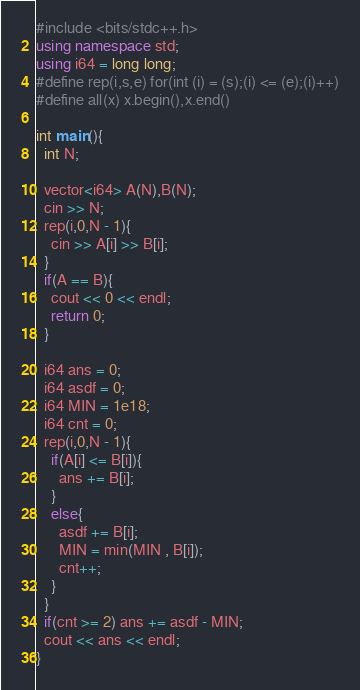Convert code to text. <code><loc_0><loc_0><loc_500><loc_500><_C++_>#include <bits/stdc++.h>
using namespace std;
using i64 = long long;
#define rep(i,s,e) for(int (i) = (s);(i) <= (e);(i)++)
#define all(x) x.begin(),x.end()

int main(){
  int N;
 
  vector<i64> A(N),B(N);
  cin >> N;
  rep(i,0,N - 1){
    cin >> A[i] >> B[i];
  }
  if(A == B){
    cout << 0 << endl;
    return 0;
  }

  i64 ans = 0;
  i64 asdf = 0;
  i64 MIN = 1e18;
  i64 cnt = 0;
  rep(i,0,N - 1){
    if(A[i] <= B[i]){
      ans += B[i];
    }
    else{
      asdf += B[i];
      MIN = min(MIN , B[i]);
      cnt++;
    }
  }
  if(cnt >= 2) ans += asdf - MIN;
  cout << ans << endl;
}
</code> 